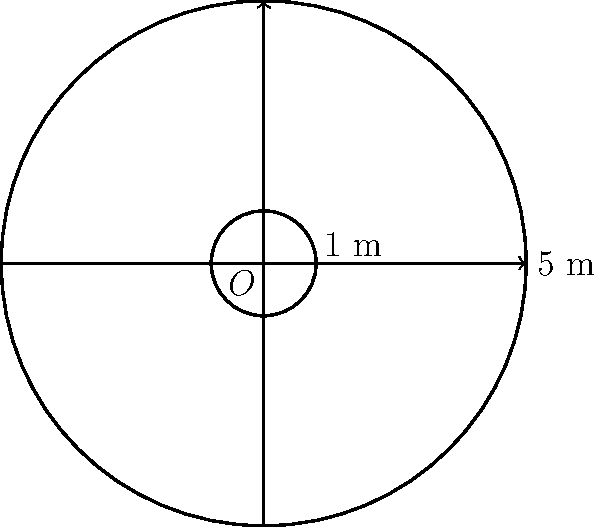In a hurling match at Semple Stadium, Thurles, you notice the circular scoring zone. The outer circle has a radius of 5 meters, while the inner circle (representing the goal area) has a radius of 1 meter. What is the area of the scoring zone between these two circles? Let's approach this step-by-step:

1) The area we're looking for is the difference between the areas of the larger and smaller circles.

2) Area of a circle is given by the formula $A = \pi r^2$, where $r$ is the radius.

3) For the larger circle:
   $A_1 = \pi (5\text{ m})^2 = 25\pi \text{ m}^2$

4) For the smaller circle:
   $A_2 = \pi (1\text{ m})^2 = \pi \text{ m}^2$

5) The area of the scoring zone is:
   $A_{\text{zone}} = A_1 - A_2 = 25\pi \text{ m}^2 - \pi \text{ m}^2 = 24\pi \text{ m}^2$

6) To get the final answer in square meters:
   $A_{\text{zone}} = 24\pi \text{ m}^2 \approx 75.40 \text{ m}^2$
Answer: $75.40 \text{ m}^2$ 